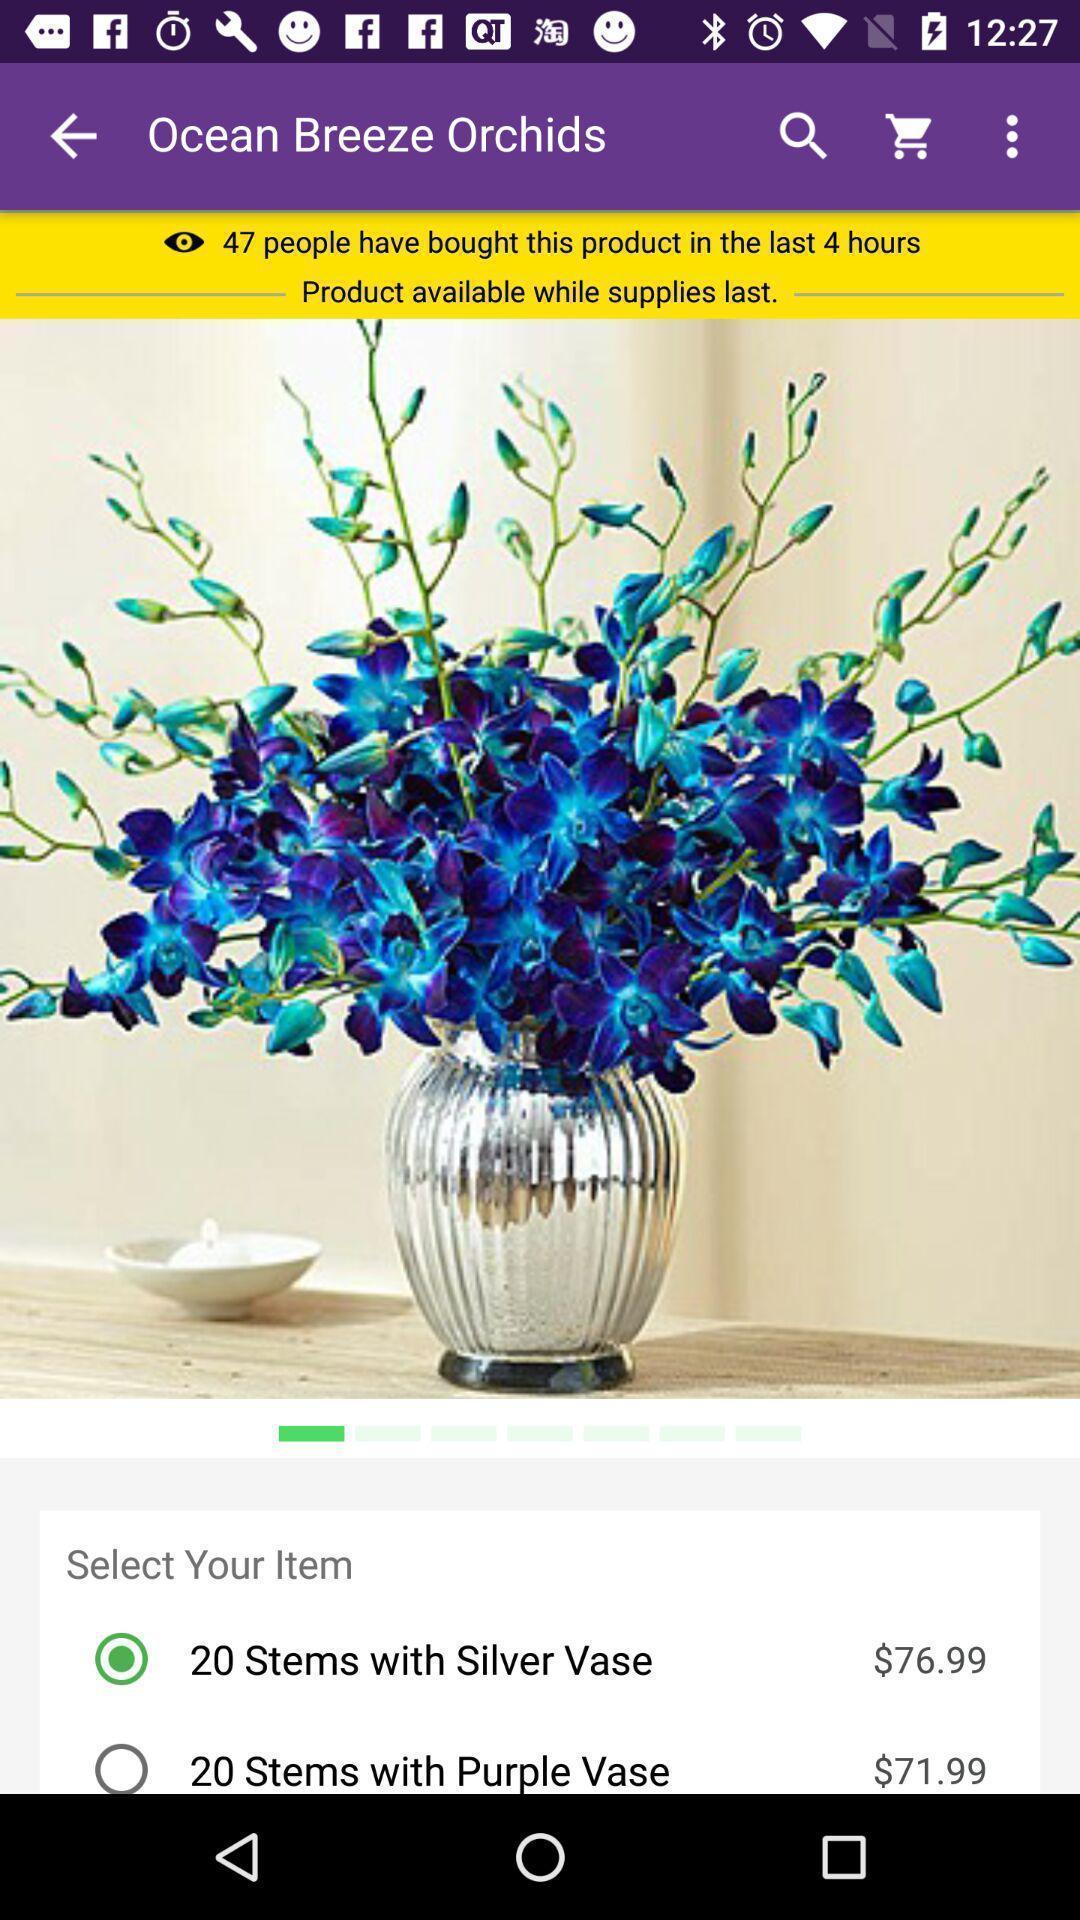Provide a detailed account of this screenshot. Page showing a product in a flowers delivery app. 